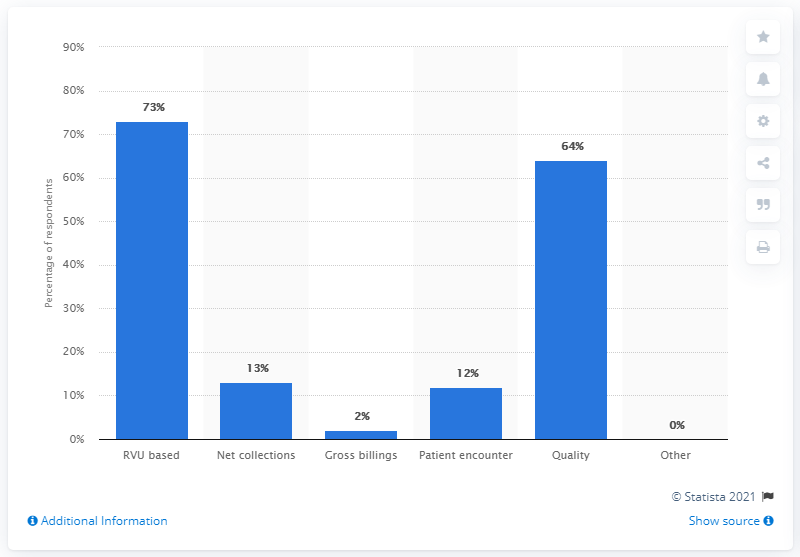Highlight a few significant elements in this photo. The most common form of salary plus production bonus incentives was RVU-based, which rewarded physicians for meeting specific quality and productivity targets. 73% of all salary plus production bonus incentives offered to physicians were based on RVU in the given time period. 